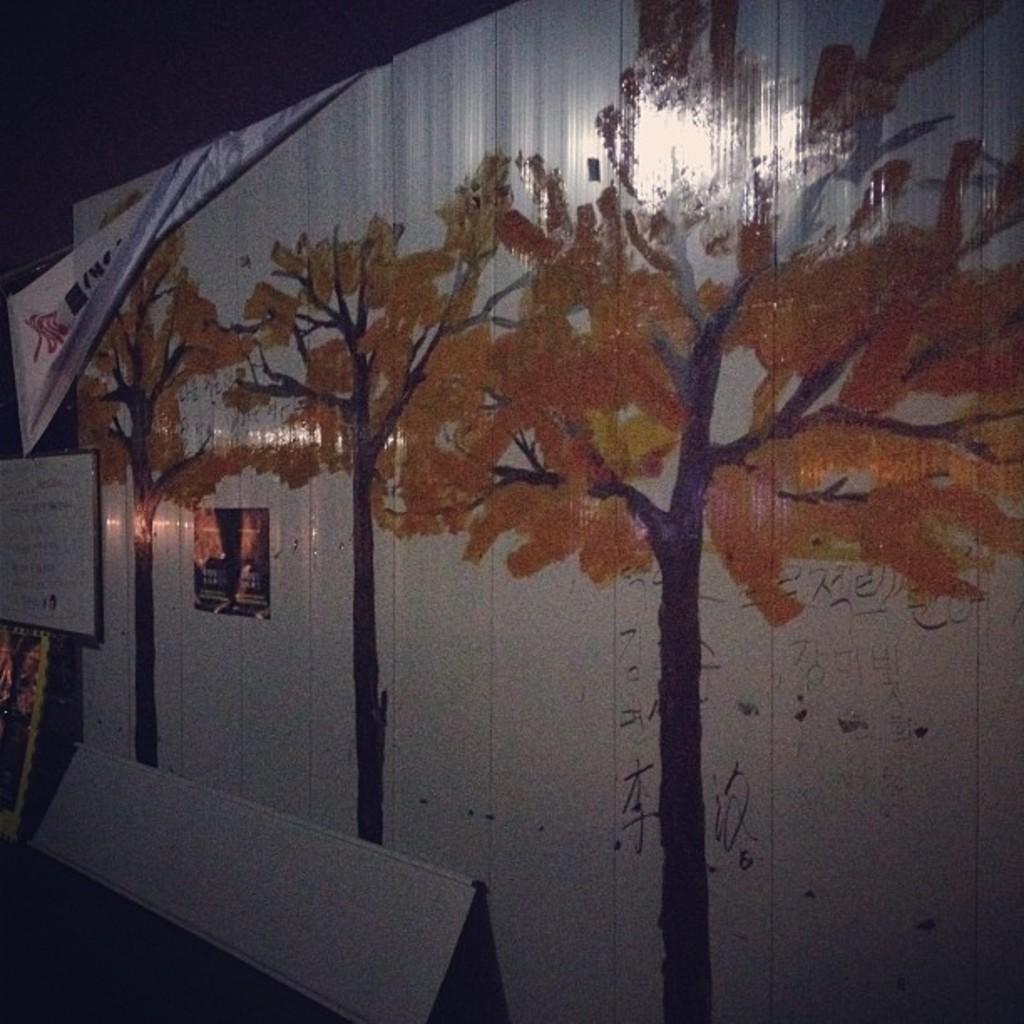What is depicted on the painting that is on the wall? There is a painting of trees on the wall. Can you describe anything behind the wall? There is a small stand behind the wall. How many dogs are sitting on the cable in the image? There are no dogs or cables present in the image. 